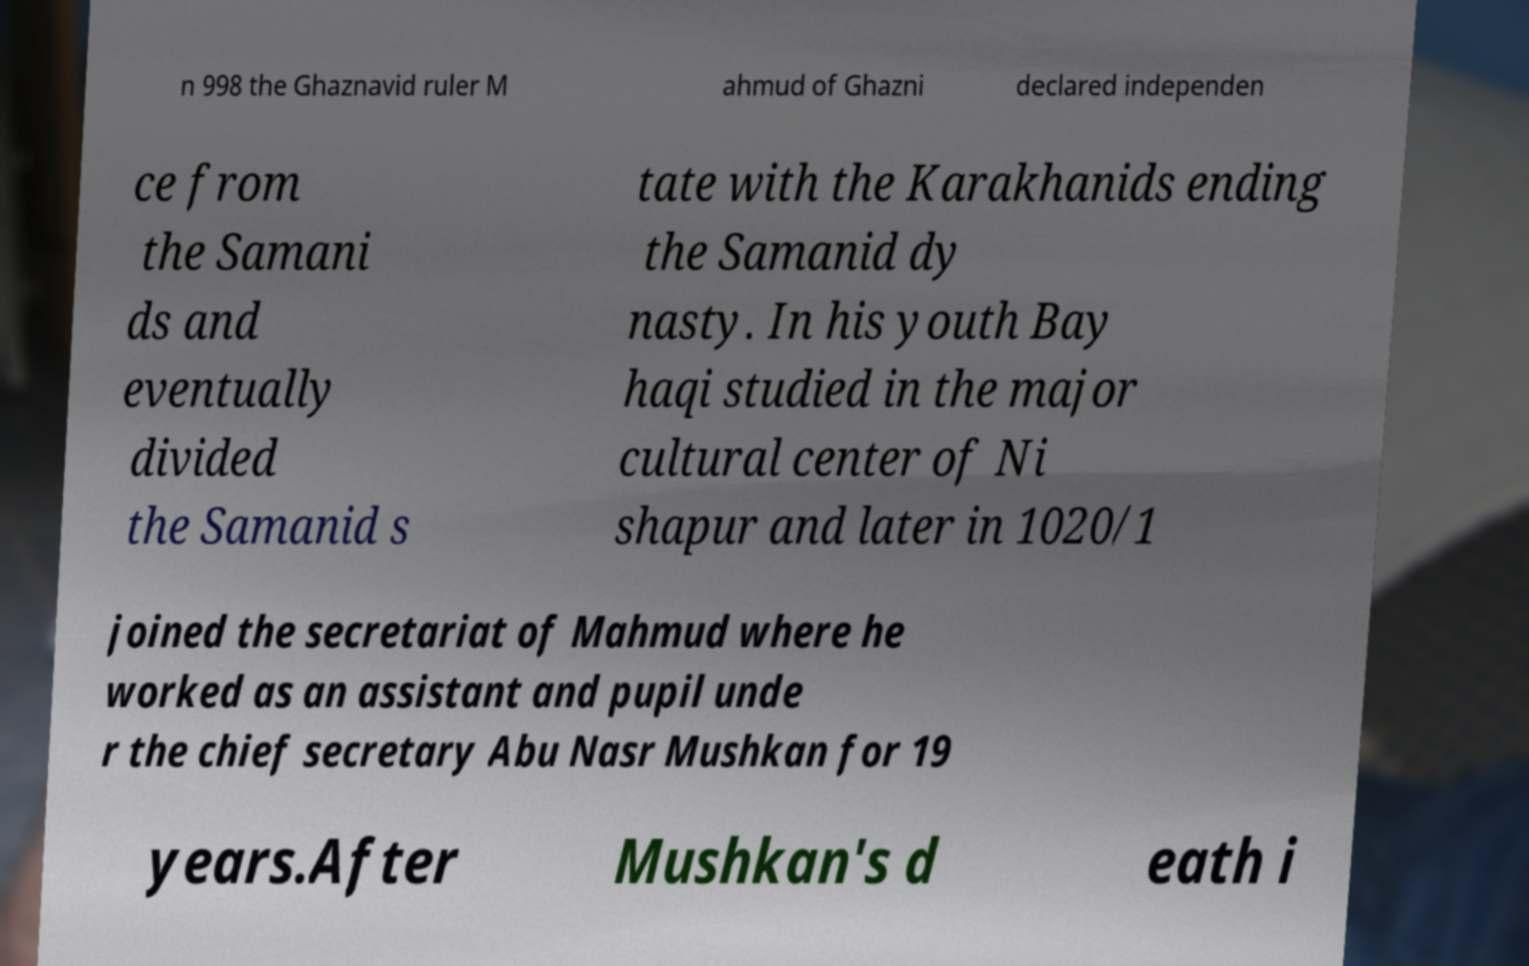I need the written content from this picture converted into text. Can you do that? n 998 the Ghaznavid ruler M ahmud of Ghazni declared independen ce from the Samani ds and eventually divided the Samanid s tate with the Karakhanids ending the Samanid dy nasty. In his youth Bay haqi studied in the major cultural center of Ni shapur and later in 1020/1 joined the secretariat of Mahmud where he worked as an assistant and pupil unde r the chief secretary Abu Nasr Mushkan for 19 years.After Mushkan's d eath i 